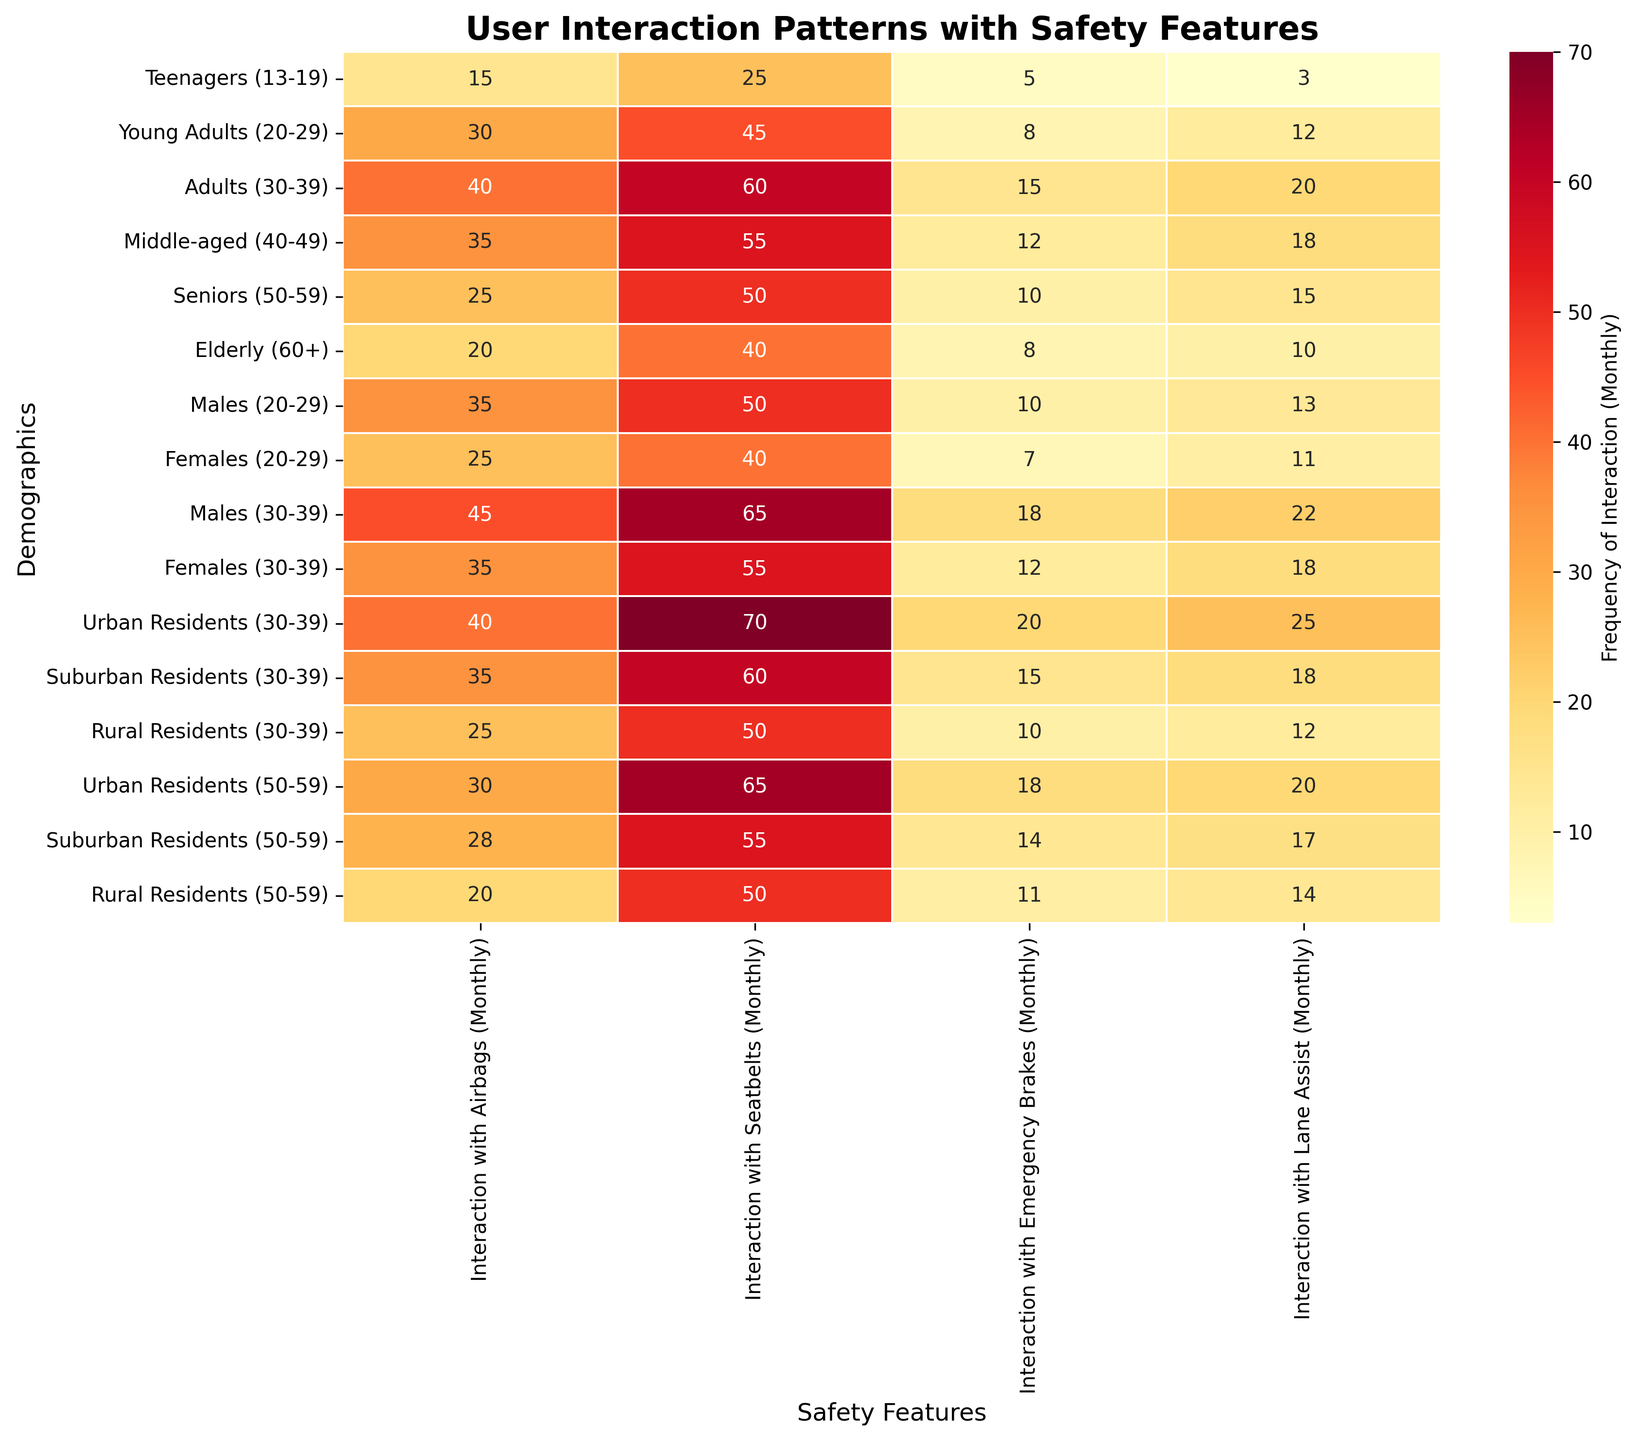Which demographic group has the highest interaction with seatbelts? By looking at the heatmap, the "Adults, 30-39" group has the highest number (60) for seatbelt interactions.
Answer: Adults, 30-39 What is the title of the heatmap? The title can be found at the top of the heatmap. It is "User Interaction Patterns with Safety Features."
Answer: User Interaction Patterns with Safety Features Which safety feature do Urban Residents (30-39) interact with the most? Refer to the row corresponding to "Urban Residents (30-39)" and identify the highest value, which is 70 for seatbelts.
Answer: Seatbelts Compare the interaction with airbags between Males (20-29) and Females (20-29). Who has more interactions? Look at the rows for "Males, 20-29" and "Females, 20-29." Males have 35 interactions, while Females have 25 interactions.
Answer: Males What is the median interaction with lane assist among all demographics? First, list out all the interactions with lane assist: 3, 12, 20, 18, 15, 10, 13, 11, 22, 18, 25, 18, 12, 20, 17, 14. Arrange them in order: 3, 10, 11, 12, 12, 13, 14, 15, 17, 18, 18, 18, 20, 20, 22, 25. The median falls between the 8th and 9th values (15 and 17), thus the median is (15 + 17) / 2 = 16.
Answer: 16 Which demographic has the least interaction with emergency brakes? Look at the column for emergency brakes and find the smallest value, which is 5, corresponding to "Teenagers, 13-19."
Answer: Teenagers, 13-19 What is the sum of interactions with airbags and emergency brakes for the "Middle-aged, 40-49" group? Add the interactions for airbags (35) and emergency brakes (12) for the "Middle-aged, 40-49" group. 35 + 12 = 47.
Answer: 47 Which demographic group has the highest difference between the interaction with airbags and lane assist? Calculate the difference for each demographic and identify the highest value:
- Teenagers: 15 - 3 = 12
- Young Adults: 30 - 12 = 18
- Adults: 40 - 20 = 20
- Middle-aged: 35 - 18 = 17
- Seniors: 25 - 15 = 10
- Elderly: 20 - 10 = 10
- Males (20-29): 35 - 13 = 22
- Females (20-29): 25 - 11 = 14
- Males (30-39): 45 - 22 = 23
- Females (30-39): 35 - 18 = 17
- Urban Residents (30-39): 40 - 25 = 15
- Suburban Residents (30-39): 35 - 18 = 17
- Rural Residents (30-39): 25 - 12 = 13
- Urban Residents (50-59): 30 - 20 = 10
- Suburban Residents (50-59): 28 - 17 = 11
- Rural Residents (50-59): 20 - 14 = 6
The highest difference is 23 for Males (30-39).
Answer: Males, 30-39 